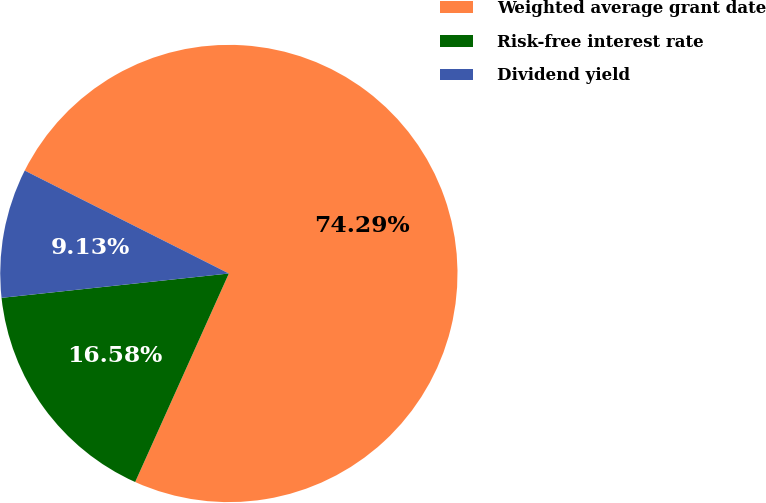Convert chart. <chart><loc_0><loc_0><loc_500><loc_500><pie_chart><fcel>Weighted average grant date<fcel>Risk-free interest rate<fcel>Dividend yield<nl><fcel>74.29%<fcel>16.58%<fcel>9.13%<nl></chart> 